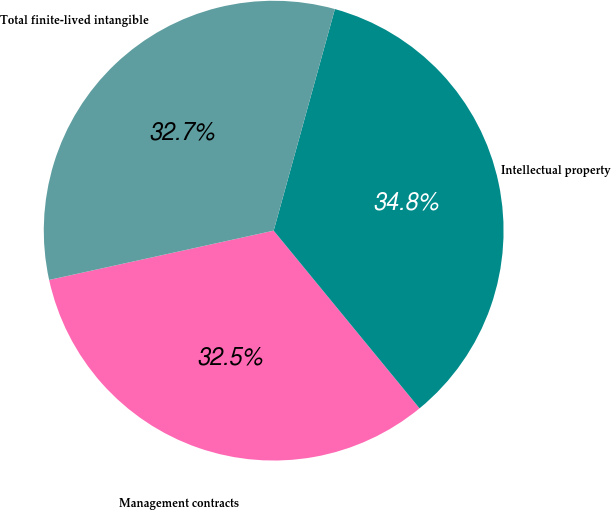<chart> <loc_0><loc_0><loc_500><loc_500><pie_chart><fcel>Management contracts<fcel>Intellectual property<fcel>Total finite-lived intangible<nl><fcel>32.5%<fcel>34.77%<fcel>32.73%<nl></chart> 